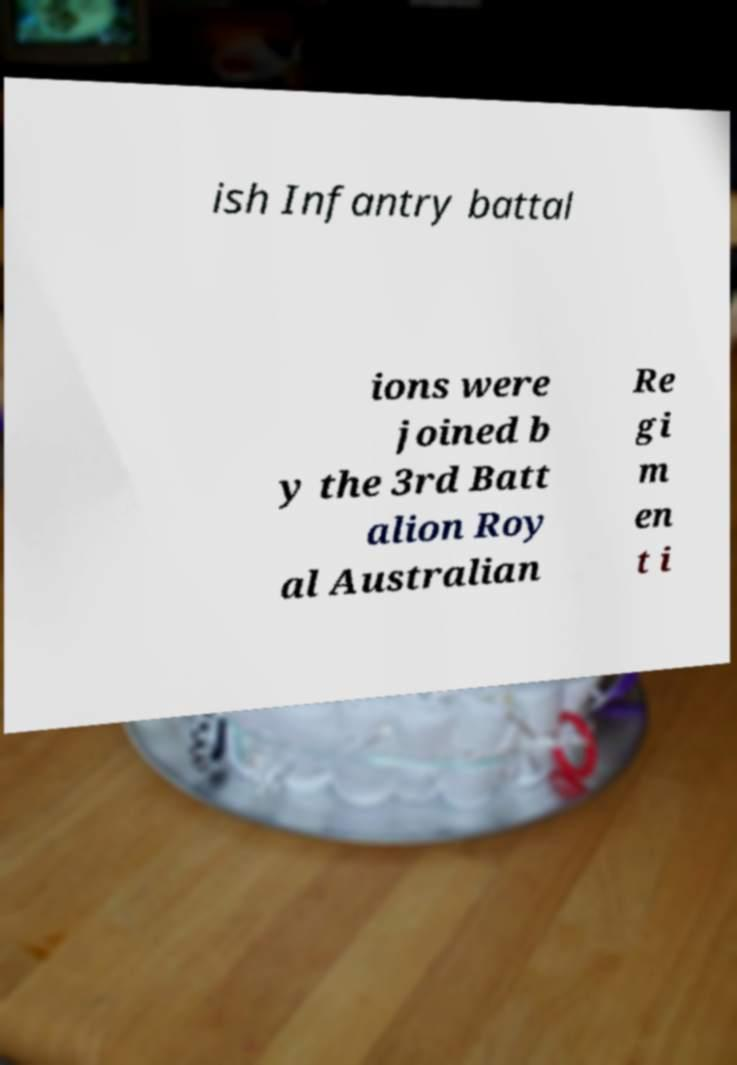There's text embedded in this image that I need extracted. Can you transcribe it verbatim? ish Infantry battal ions were joined b y the 3rd Batt alion Roy al Australian Re gi m en t i 